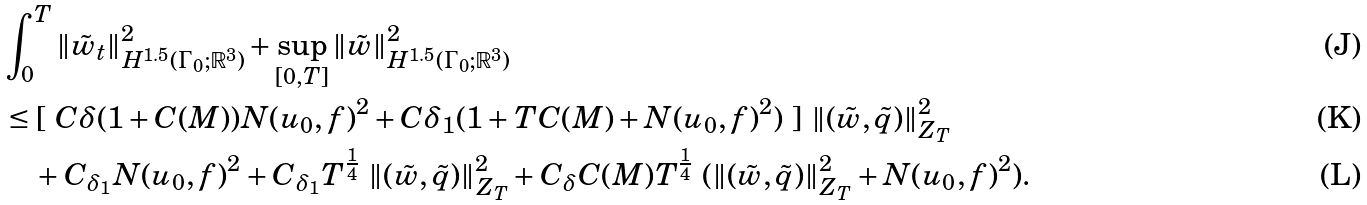<formula> <loc_0><loc_0><loc_500><loc_500>& \int _ { 0 } ^ { T } \| { \tilde { w } _ { t } } \| ^ { 2 } _ { H ^ { 1 . 5 } ( \Gamma _ { 0 } ; { \mathbb { R } } ^ { 3 } ) } + \sup _ { [ 0 , T ] } \| \tilde { w } \| ^ { 2 } _ { H ^ { 1 . 5 } ( \Gamma _ { 0 } ; { \mathbb { R } } ^ { 3 } ) } \\ & \leq [ \ C \delta ( 1 + C ( M ) ) N ( u _ { 0 } , f ) ^ { 2 } + C \delta _ { 1 } ( 1 + T C ( M ) + N ( u _ { 0 } , f ) ^ { 2 } ) \ ] \ \| ( \tilde { w } , \tilde { q } ) \| ^ { 2 } _ { Z _ { T } } \\ & \quad + C _ { \delta _ { 1 } } N ( u _ { 0 } , f ) ^ { 2 } + C _ { \delta _ { 1 } } T ^ { \frac { 1 } { 4 } } \ \| ( \tilde { w } , \tilde { q } ) \| ^ { 2 } _ { Z _ { T } } + C _ { \delta } C ( M ) T ^ { \frac { 1 } { 4 } } \ ( \| ( \tilde { w } , \tilde { q } ) \| ^ { 2 } _ { Z _ { T } } + N ( u _ { 0 } , f ) ^ { 2 } ) .</formula> 